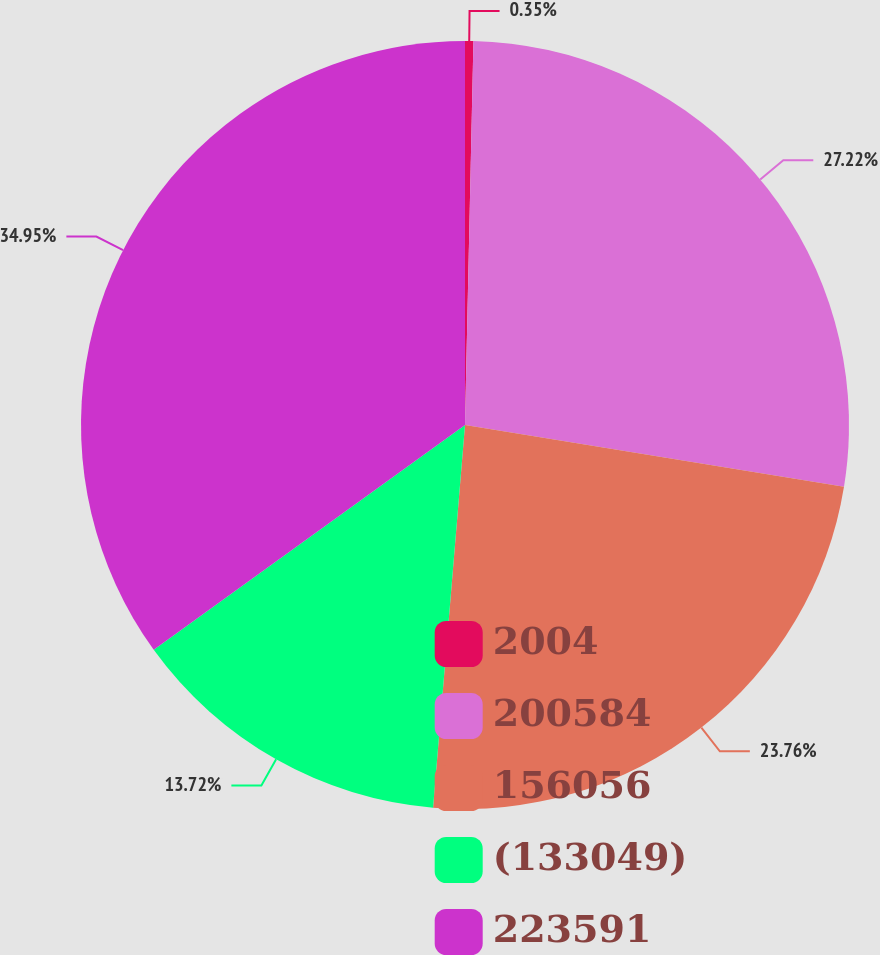<chart> <loc_0><loc_0><loc_500><loc_500><pie_chart><fcel>2004<fcel>200584<fcel>156056<fcel>(133049)<fcel>223591<nl><fcel>0.35%<fcel>27.22%<fcel>23.76%<fcel>13.72%<fcel>34.96%<nl></chart> 